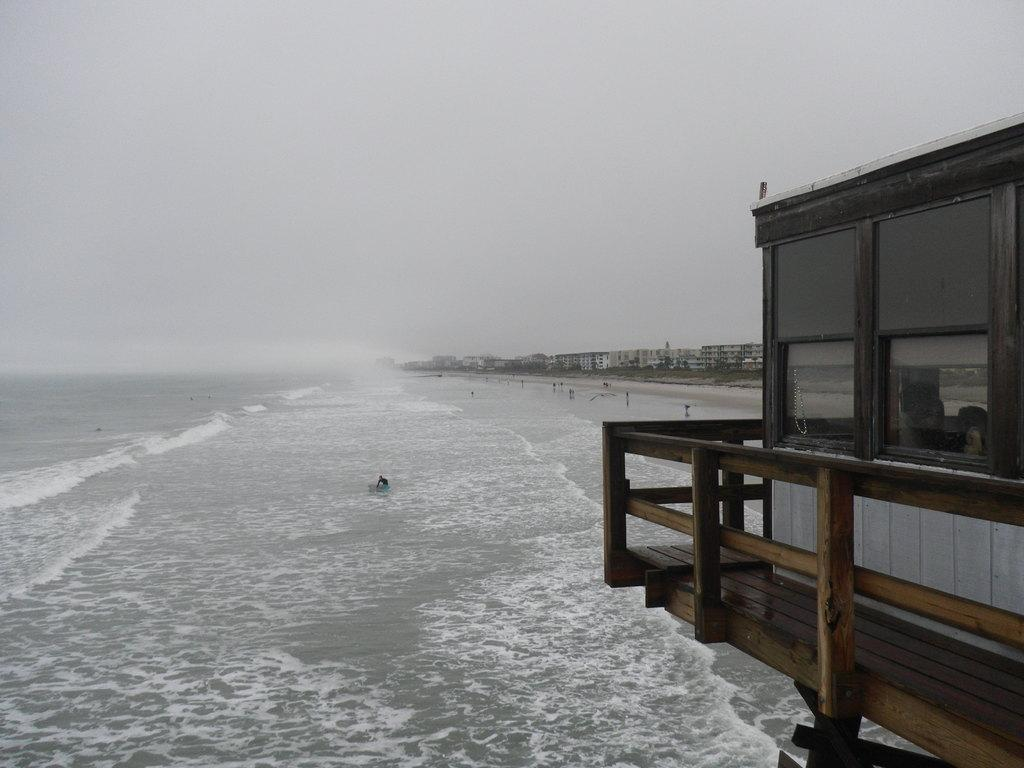What structure can be seen in the image? There is a watch tower in the image. What natural element is visible in the image? There is water visible in the image. Who or what is present in the image? There are people in the image. What can be seen in the distance in the image? There are buildings in the background of the image. What part of the natural environment is visible in the image? The sky is visible in the background of the image. What type of drug is being used by the people in the image? There is no indication in the image that the people are using any drugs, so it cannot be determined from the picture. 